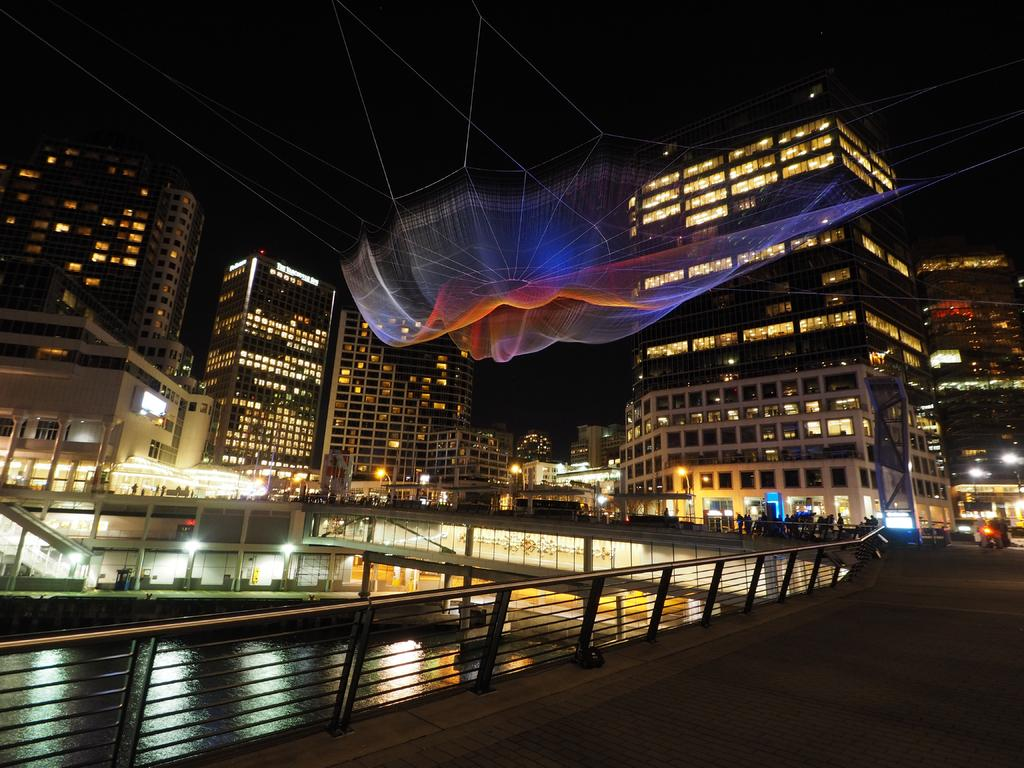What type of structure can be seen in the image? There is a railing in the image. What type of pathway is visible in the image? There is a road in the image. What natural feature is present in the image? There is a water body in the image. Are there any living beings in the image? Yes, there are humans in the image. What type of man-made structures are visible in the image? There are buildings in the image. What object is located in the middle of the image? There is a net in the middle of the image. How would you describe the lighting in the image? The background of the image appears dark. What type of engine is powering the tramp in the image? There is no tramp or engine present in the image. What scientific theory is being demonstrated in the image? There is no scientific theory being demonstrated in the image. 